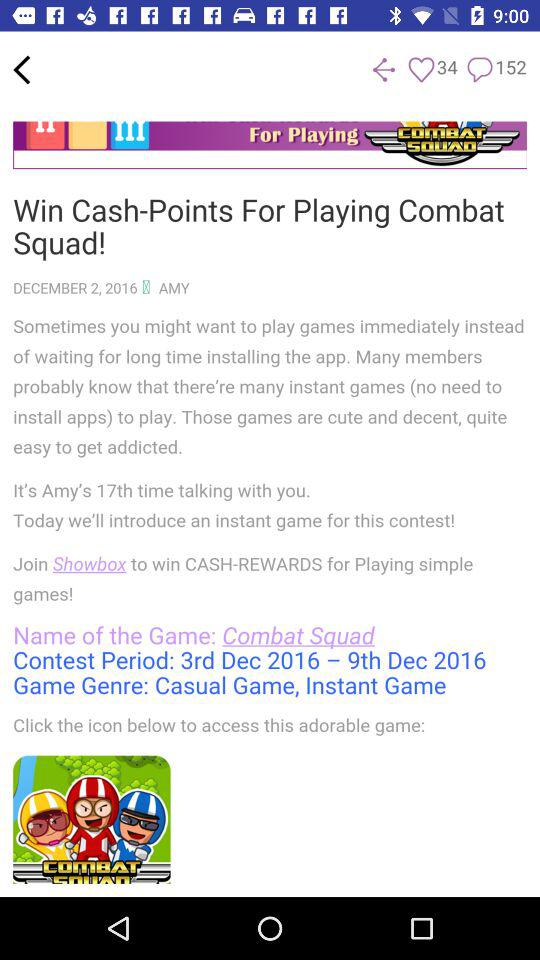What is the name of the game? The name of the game is "Combat Squad". 